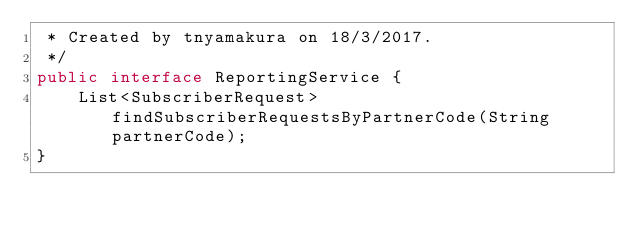<code> <loc_0><loc_0><loc_500><loc_500><_Java_> * Created by tnyamakura on 18/3/2017.
 */
public interface ReportingService {
    List<SubscriberRequest> findSubscriberRequestsByPartnerCode(String partnerCode);
}
</code> 